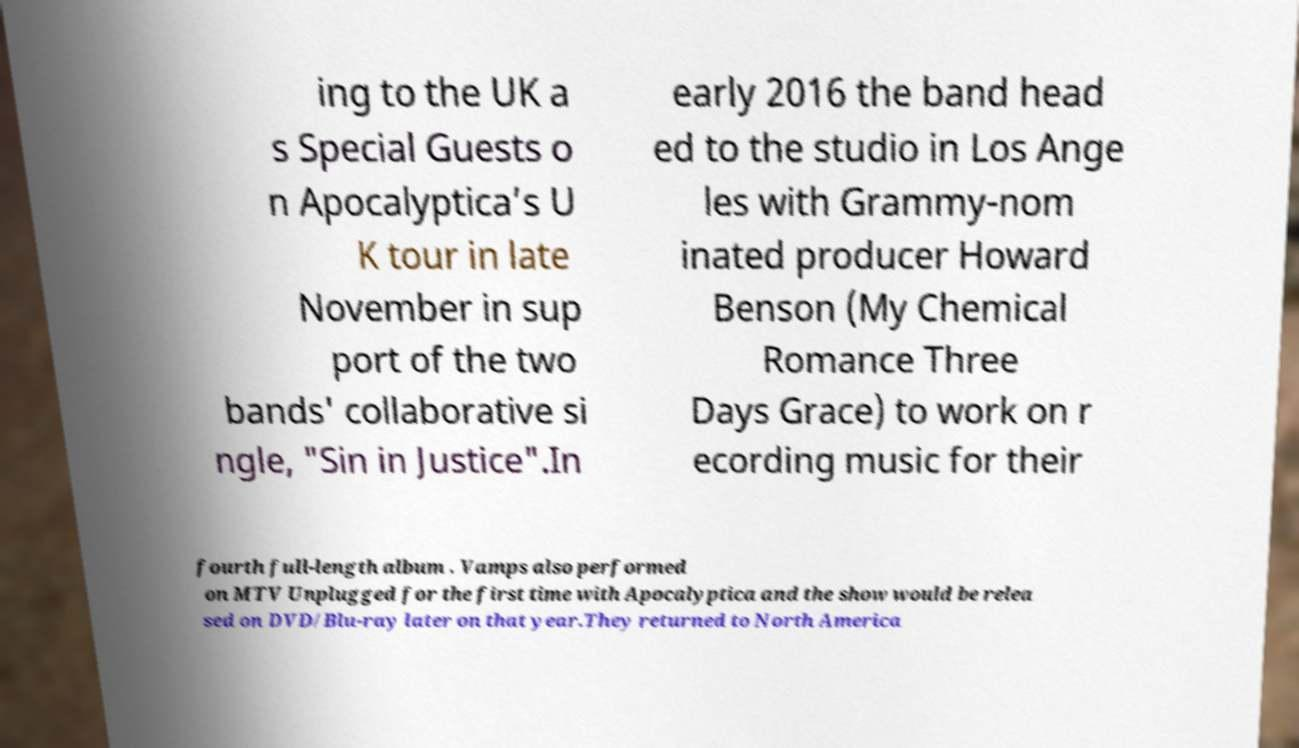For documentation purposes, I need the text within this image transcribed. Could you provide that? ing to the UK a s Special Guests o n Apocalyptica’s U K tour in late November in sup port of the two bands' collaborative si ngle, "Sin in Justice".In early 2016 the band head ed to the studio in Los Ange les with Grammy-nom inated producer Howard Benson (My Chemical Romance Three Days Grace) to work on r ecording music for their fourth full-length album . Vamps also performed on MTV Unplugged for the first time with Apocalyptica and the show would be relea sed on DVD/Blu-ray later on that year.They returned to North America 